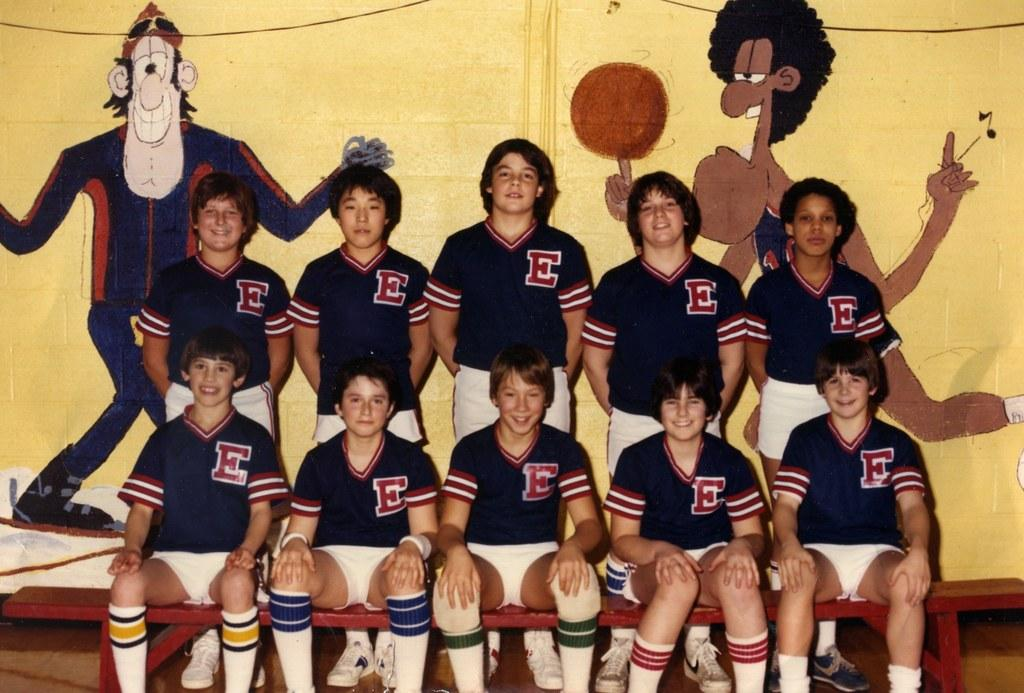<image>
Provide a brief description of the given image. Young men on a team have the letter "E" on their uniforms. 